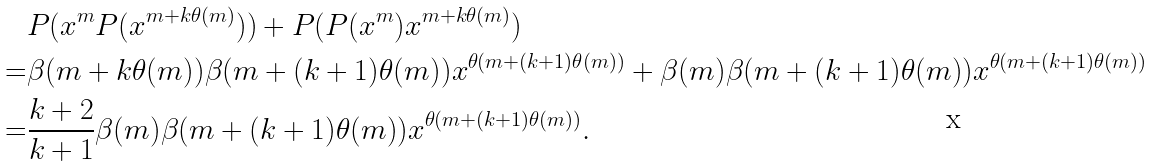<formula> <loc_0><loc_0><loc_500><loc_500>& P ( x ^ { m } P ( x ^ { m + k \theta ( m ) } ) ) + P ( P ( x ^ { m } ) x ^ { m + k \theta ( m ) } ) \\ = & \beta ( m + k \theta ( m ) ) \beta ( m + ( k + 1 ) \theta ( m ) ) x ^ { \theta ( m + ( k + 1 ) \theta ( m ) ) } + \beta ( m ) \beta ( m + ( k + 1 ) \theta ( m ) ) x ^ { \theta ( m + ( k + 1 ) \theta ( m ) ) } \\ = & \frac { k + 2 } { k + 1 } \beta ( m ) \beta ( m + ( k + 1 ) \theta ( m ) ) x ^ { \theta ( m + ( k + 1 ) \theta ( m ) ) } .</formula> 